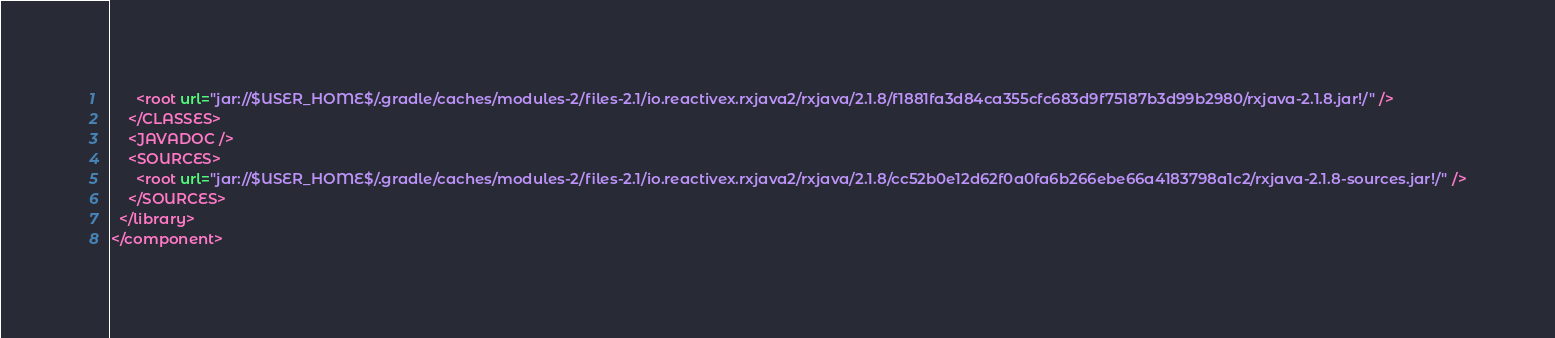<code> <loc_0><loc_0><loc_500><loc_500><_XML_>      <root url="jar://$USER_HOME$/.gradle/caches/modules-2/files-2.1/io.reactivex.rxjava2/rxjava/2.1.8/f1881fa3d84ca355cfc683d9f75187b3d99b2980/rxjava-2.1.8.jar!/" />
    </CLASSES>
    <JAVADOC />
    <SOURCES>
      <root url="jar://$USER_HOME$/.gradle/caches/modules-2/files-2.1/io.reactivex.rxjava2/rxjava/2.1.8/cc52b0e12d62f0a0fa6b266ebe66a4183798a1c2/rxjava-2.1.8-sources.jar!/" />
    </SOURCES>
  </library>
</component></code> 